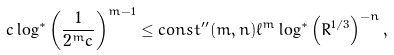Convert formula to latex. <formula><loc_0><loc_0><loc_500><loc_500>c \log ^ { * } \left ( \frac { 1 } { 2 ^ { m } c } \right ) ^ { m - 1 } \leq c o n s t ^ { \prime \prime } ( m , n ) \ell ^ { m } \log ^ { * } \left ( R ^ { 1 / 3 } \right ) ^ { - n } ,</formula> 